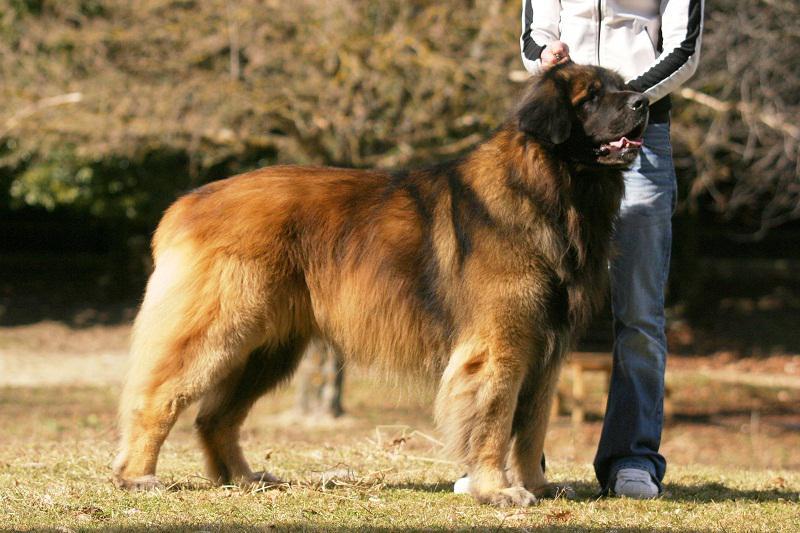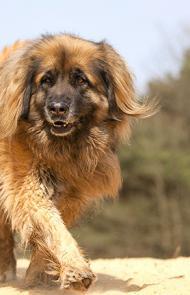The first image is the image on the left, the second image is the image on the right. For the images shown, is this caption "An image shows at least one dog that is walking forward, with one front paw in front of the other." true? Answer yes or no. Yes. 